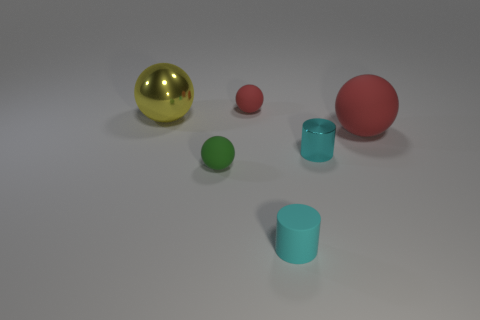Is the number of red rubber spheres right of the tiny cyan rubber thing greater than the number of big yellow metallic spheres?
Your answer should be compact. No. What is the size of the green rubber thing that is the same shape as the large metal object?
Keep it short and to the point. Small. Are there any other things that have the same material as the green thing?
Make the answer very short. Yes. What is the shape of the tiny cyan metallic object?
Offer a very short reply. Cylinder. There is a green thing that is the same size as the cyan metallic cylinder; what is its shape?
Keep it short and to the point. Sphere. Is there any other thing of the same color as the big shiny object?
Keep it short and to the point. No. What size is the cylinder that is the same material as the small red thing?
Offer a very short reply. Small. Does the tiny shiny object have the same shape as the red object on the left side of the big red matte sphere?
Offer a very short reply. No. How big is the shiny ball?
Provide a succinct answer. Large. Are there fewer tiny cylinders that are behind the small green sphere than tiny cyan matte things?
Provide a succinct answer. No. 